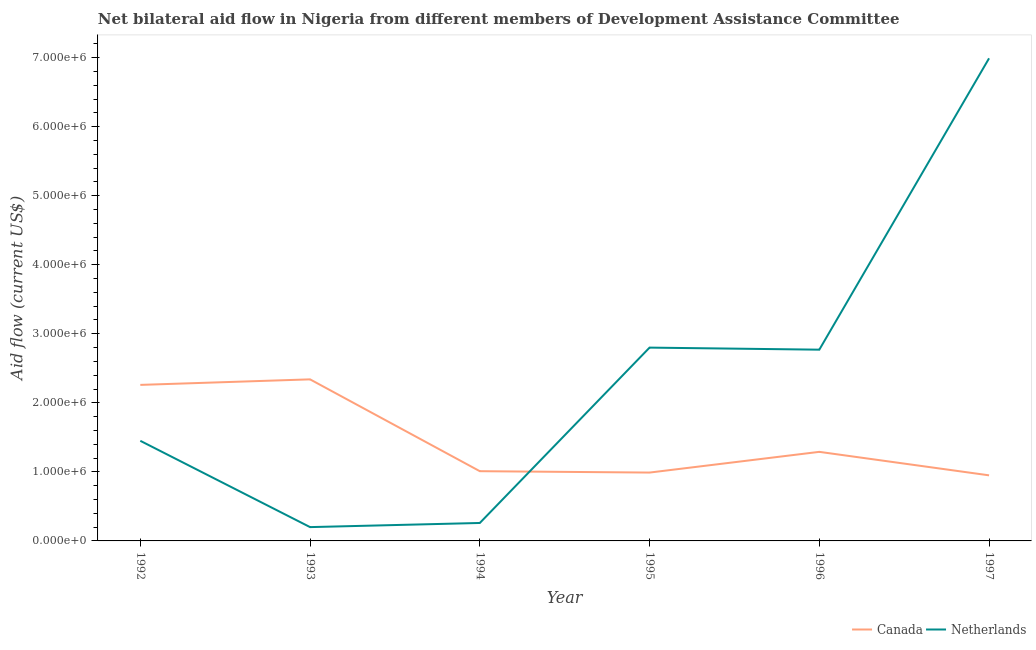How many different coloured lines are there?
Your answer should be very brief. 2. Does the line corresponding to amount of aid given by canada intersect with the line corresponding to amount of aid given by netherlands?
Your answer should be very brief. Yes. What is the amount of aid given by canada in 1992?
Provide a short and direct response. 2.26e+06. Across all years, what is the maximum amount of aid given by canada?
Offer a terse response. 2.34e+06. Across all years, what is the minimum amount of aid given by netherlands?
Ensure brevity in your answer.  2.00e+05. In which year was the amount of aid given by netherlands maximum?
Your response must be concise. 1997. In which year was the amount of aid given by canada minimum?
Keep it short and to the point. 1997. What is the total amount of aid given by canada in the graph?
Give a very brief answer. 8.84e+06. What is the difference between the amount of aid given by canada in 1996 and that in 1997?
Offer a very short reply. 3.40e+05. What is the difference between the amount of aid given by canada in 1992 and the amount of aid given by netherlands in 1993?
Keep it short and to the point. 2.06e+06. What is the average amount of aid given by canada per year?
Keep it short and to the point. 1.47e+06. In the year 1995, what is the difference between the amount of aid given by canada and amount of aid given by netherlands?
Offer a very short reply. -1.81e+06. In how many years, is the amount of aid given by netherlands greater than 1000000 US$?
Provide a succinct answer. 4. What is the ratio of the amount of aid given by canada in 1993 to that in 1997?
Your answer should be very brief. 2.46. Is the amount of aid given by netherlands in 1992 less than that in 1995?
Your response must be concise. Yes. What is the difference between the highest and the second highest amount of aid given by netherlands?
Ensure brevity in your answer.  4.19e+06. What is the difference between the highest and the lowest amount of aid given by netherlands?
Provide a short and direct response. 6.79e+06. Does the amount of aid given by canada monotonically increase over the years?
Ensure brevity in your answer.  No. Is the amount of aid given by netherlands strictly less than the amount of aid given by canada over the years?
Provide a succinct answer. No. What is the difference between two consecutive major ticks on the Y-axis?
Ensure brevity in your answer.  1.00e+06. Are the values on the major ticks of Y-axis written in scientific E-notation?
Keep it short and to the point. Yes. Does the graph contain any zero values?
Keep it short and to the point. No. What is the title of the graph?
Your response must be concise. Net bilateral aid flow in Nigeria from different members of Development Assistance Committee. What is the label or title of the X-axis?
Your response must be concise. Year. What is the Aid flow (current US$) in Canada in 1992?
Offer a terse response. 2.26e+06. What is the Aid flow (current US$) of Netherlands in 1992?
Provide a succinct answer. 1.45e+06. What is the Aid flow (current US$) in Canada in 1993?
Make the answer very short. 2.34e+06. What is the Aid flow (current US$) in Netherlands in 1993?
Offer a very short reply. 2.00e+05. What is the Aid flow (current US$) of Canada in 1994?
Make the answer very short. 1.01e+06. What is the Aid flow (current US$) of Netherlands in 1994?
Give a very brief answer. 2.60e+05. What is the Aid flow (current US$) of Canada in 1995?
Your answer should be compact. 9.90e+05. What is the Aid flow (current US$) in Netherlands in 1995?
Your answer should be compact. 2.80e+06. What is the Aid flow (current US$) in Canada in 1996?
Make the answer very short. 1.29e+06. What is the Aid flow (current US$) in Netherlands in 1996?
Keep it short and to the point. 2.77e+06. What is the Aid flow (current US$) of Canada in 1997?
Give a very brief answer. 9.50e+05. What is the Aid flow (current US$) in Netherlands in 1997?
Ensure brevity in your answer.  6.99e+06. Across all years, what is the maximum Aid flow (current US$) in Canada?
Keep it short and to the point. 2.34e+06. Across all years, what is the maximum Aid flow (current US$) in Netherlands?
Keep it short and to the point. 6.99e+06. Across all years, what is the minimum Aid flow (current US$) in Canada?
Provide a succinct answer. 9.50e+05. What is the total Aid flow (current US$) of Canada in the graph?
Your response must be concise. 8.84e+06. What is the total Aid flow (current US$) in Netherlands in the graph?
Offer a very short reply. 1.45e+07. What is the difference between the Aid flow (current US$) of Netherlands in 1992 and that in 1993?
Offer a very short reply. 1.25e+06. What is the difference between the Aid flow (current US$) in Canada in 1992 and that in 1994?
Give a very brief answer. 1.25e+06. What is the difference between the Aid flow (current US$) of Netherlands in 1992 and that in 1994?
Give a very brief answer. 1.19e+06. What is the difference between the Aid flow (current US$) in Canada in 1992 and that in 1995?
Provide a short and direct response. 1.27e+06. What is the difference between the Aid flow (current US$) of Netherlands in 1992 and that in 1995?
Your response must be concise. -1.35e+06. What is the difference between the Aid flow (current US$) of Canada in 1992 and that in 1996?
Ensure brevity in your answer.  9.70e+05. What is the difference between the Aid flow (current US$) of Netherlands in 1992 and that in 1996?
Provide a succinct answer. -1.32e+06. What is the difference between the Aid flow (current US$) in Canada in 1992 and that in 1997?
Ensure brevity in your answer.  1.31e+06. What is the difference between the Aid flow (current US$) in Netherlands in 1992 and that in 1997?
Offer a very short reply. -5.54e+06. What is the difference between the Aid flow (current US$) in Canada in 1993 and that in 1994?
Your answer should be compact. 1.33e+06. What is the difference between the Aid flow (current US$) in Netherlands in 1993 and that in 1994?
Make the answer very short. -6.00e+04. What is the difference between the Aid flow (current US$) in Canada in 1993 and that in 1995?
Keep it short and to the point. 1.35e+06. What is the difference between the Aid flow (current US$) of Netherlands in 1993 and that in 1995?
Provide a short and direct response. -2.60e+06. What is the difference between the Aid flow (current US$) of Canada in 1993 and that in 1996?
Offer a very short reply. 1.05e+06. What is the difference between the Aid flow (current US$) of Netherlands in 1993 and that in 1996?
Your answer should be compact. -2.57e+06. What is the difference between the Aid flow (current US$) in Canada in 1993 and that in 1997?
Your response must be concise. 1.39e+06. What is the difference between the Aid flow (current US$) in Netherlands in 1993 and that in 1997?
Keep it short and to the point. -6.79e+06. What is the difference between the Aid flow (current US$) in Netherlands in 1994 and that in 1995?
Keep it short and to the point. -2.54e+06. What is the difference between the Aid flow (current US$) of Canada in 1994 and that in 1996?
Keep it short and to the point. -2.80e+05. What is the difference between the Aid flow (current US$) of Netherlands in 1994 and that in 1996?
Offer a very short reply. -2.51e+06. What is the difference between the Aid flow (current US$) of Netherlands in 1994 and that in 1997?
Keep it short and to the point. -6.73e+06. What is the difference between the Aid flow (current US$) of Netherlands in 1995 and that in 1996?
Your response must be concise. 3.00e+04. What is the difference between the Aid flow (current US$) of Netherlands in 1995 and that in 1997?
Offer a terse response. -4.19e+06. What is the difference between the Aid flow (current US$) in Canada in 1996 and that in 1997?
Offer a terse response. 3.40e+05. What is the difference between the Aid flow (current US$) in Netherlands in 1996 and that in 1997?
Provide a succinct answer. -4.22e+06. What is the difference between the Aid flow (current US$) of Canada in 1992 and the Aid flow (current US$) of Netherlands in 1993?
Make the answer very short. 2.06e+06. What is the difference between the Aid flow (current US$) of Canada in 1992 and the Aid flow (current US$) of Netherlands in 1995?
Your answer should be compact. -5.40e+05. What is the difference between the Aid flow (current US$) of Canada in 1992 and the Aid flow (current US$) of Netherlands in 1996?
Provide a short and direct response. -5.10e+05. What is the difference between the Aid flow (current US$) of Canada in 1992 and the Aid flow (current US$) of Netherlands in 1997?
Your response must be concise. -4.73e+06. What is the difference between the Aid flow (current US$) of Canada in 1993 and the Aid flow (current US$) of Netherlands in 1994?
Your answer should be very brief. 2.08e+06. What is the difference between the Aid flow (current US$) in Canada in 1993 and the Aid flow (current US$) in Netherlands in 1995?
Your answer should be compact. -4.60e+05. What is the difference between the Aid flow (current US$) of Canada in 1993 and the Aid flow (current US$) of Netherlands in 1996?
Provide a succinct answer. -4.30e+05. What is the difference between the Aid flow (current US$) in Canada in 1993 and the Aid flow (current US$) in Netherlands in 1997?
Ensure brevity in your answer.  -4.65e+06. What is the difference between the Aid flow (current US$) of Canada in 1994 and the Aid flow (current US$) of Netherlands in 1995?
Give a very brief answer. -1.79e+06. What is the difference between the Aid flow (current US$) of Canada in 1994 and the Aid flow (current US$) of Netherlands in 1996?
Provide a short and direct response. -1.76e+06. What is the difference between the Aid flow (current US$) of Canada in 1994 and the Aid flow (current US$) of Netherlands in 1997?
Offer a terse response. -5.98e+06. What is the difference between the Aid flow (current US$) of Canada in 1995 and the Aid flow (current US$) of Netherlands in 1996?
Your answer should be compact. -1.78e+06. What is the difference between the Aid flow (current US$) of Canada in 1995 and the Aid flow (current US$) of Netherlands in 1997?
Your answer should be compact. -6.00e+06. What is the difference between the Aid flow (current US$) of Canada in 1996 and the Aid flow (current US$) of Netherlands in 1997?
Offer a terse response. -5.70e+06. What is the average Aid flow (current US$) in Canada per year?
Your answer should be compact. 1.47e+06. What is the average Aid flow (current US$) in Netherlands per year?
Offer a very short reply. 2.41e+06. In the year 1992, what is the difference between the Aid flow (current US$) of Canada and Aid flow (current US$) of Netherlands?
Make the answer very short. 8.10e+05. In the year 1993, what is the difference between the Aid flow (current US$) of Canada and Aid flow (current US$) of Netherlands?
Make the answer very short. 2.14e+06. In the year 1994, what is the difference between the Aid flow (current US$) in Canada and Aid flow (current US$) in Netherlands?
Offer a very short reply. 7.50e+05. In the year 1995, what is the difference between the Aid flow (current US$) in Canada and Aid flow (current US$) in Netherlands?
Keep it short and to the point. -1.81e+06. In the year 1996, what is the difference between the Aid flow (current US$) of Canada and Aid flow (current US$) of Netherlands?
Ensure brevity in your answer.  -1.48e+06. In the year 1997, what is the difference between the Aid flow (current US$) of Canada and Aid flow (current US$) of Netherlands?
Make the answer very short. -6.04e+06. What is the ratio of the Aid flow (current US$) in Canada in 1992 to that in 1993?
Provide a short and direct response. 0.97. What is the ratio of the Aid flow (current US$) in Netherlands in 1992 to that in 1993?
Offer a terse response. 7.25. What is the ratio of the Aid flow (current US$) of Canada in 1992 to that in 1994?
Make the answer very short. 2.24. What is the ratio of the Aid flow (current US$) in Netherlands in 1992 to that in 1994?
Make the answer very short. 5.58. What is the ratio of the Aid flow (current US$) in Canada in 1992 to that in 1995?
Your answer should be compact. 2.28. What is the ratio of the Aid flow (current US$) in Netherlands in 1992 to that in 1995?
Provide a succinct answer. 0.52. What is the ratio of the Aid flow (current US$) in Canada in 1992 to that in 1996?
Ensure brevity in your answer.  1.75. What is the ratio of the Aid flow (current US$) of Netherlands in 1992 to that in 1996?
Your answer should be very brief. 0.52. What is the ratio of the Aid flow (current US$) in Canada in 1992 to that in 1997?
Offer a very short reply. 2.38. What is the ratio of the Aid flow (current US$) of Netherlands in 1992 to that in 1997?
Offer a very short reply. 0.21. What is the ratio of the Aid flow (current US$) of Canada in 1993 to that in 1994?
Your response must be concise. 2.32. What is the ratio of the Aid flow (current US$) of Netherlands in 1993 to that in 1994?
Make the answer very short. 0.77. What is the ratio of the Aid flow (current US$) in Canada in 1993 to that in 1995?
Your response must be concise. 2.36. What is the ratio of the Aid flow (current US$) of Netherlands in 1993 to that in 1995?
Make the answer very short. 0.07. What is the ratio of the Aid flow (current US$) of Canada in 1993 to that in 1996?
Provide a succinct answer. 1.81. What is the ratio of the Aid flow (current US$) in Netherlands in 1993 to that in 1996?
Keep it short and to the point. 0.07. What is the ratio of the Aid flow (current US$) in Canada in 1993 to that in 1997?
Make the answer very short. 2.46. What is the ratio of the Aid flow (current US$) in Netherlands in 1993 to that in 1997?
Ensure brevity in your answer.  0.03. What is the ratio of the Aid flow (current US$) of Canada in 1994 to that in 1995?
Provide a succinct answer. 1.02. What is the ratio of the Aid flow (current US$) of Netherlands in 1994 to that in 1995?
Provide a succinct answer. 0.09. What is the ratio of the Aid flow (current US$) in Canada in 1994 to that in 1996?
Offer a very short reply. 0.78. What is the ratio of the Aid flow (current US$) of Netherlands in 1994 to that in 1996?
Offer a very short reply. 0.09. What is the ratio of the Aid flow (current US$) of Canada in 1994 to that in 1997?
Ensure brevity in your answer.  1.06. What is the ratio of the Aid flow (current US$) in Netherlands in 1994 to that in 1997?
Your response must be concise. 0.04. What is the ratio of the Aid flow (current US$) in Canada in 1995 to that in 1996?
Make the answer very short. 0.77. What is the ratio of the Aid flow (current US$) in Netherlands in 1995 to that in 1996?
Provide a short and direct response. 1.01. What is the ratio of the Aid flow (current US$) in Canada in 1995 to that in 1997?
Keep it short and to the point. 1.04. What is the ratio of the Aid flow (current US$) in Netherlands in 1995 to that in 1997?
Your response must be concise. 0.4. What is the ratio of the Aid flow (current US$) of Canada in 1996 to that in 1997?
Offer a very short reply. 1.36. What is the ratio of the Aid flow (current US$) in Netherlands in 1996 to that in 1997?
Provide a succinct answer. 0.4. What is the difference between the highest and the second highest Aid flow (current US$) of Canada?
Give a very brief answer. 8.00e+04. What is the difference between the highest and the second highest Aid flow (current US$) of Netherlands?
Offer a terse response. 4.19e+06. What is the difference between the highest and the lowest Aid flow (current US$) of Canada?
Provide a succinct answer. 1.39e+06. What is the difference between the highest and the lowest Aid flow (current US$) in Netherlands?
Offer a terse response. 6.79e+06. 